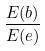<formula> <loc_0><loc_0><loc_500><loc_500>\frac { E ( b ) } { E ( e ) }</formula> 